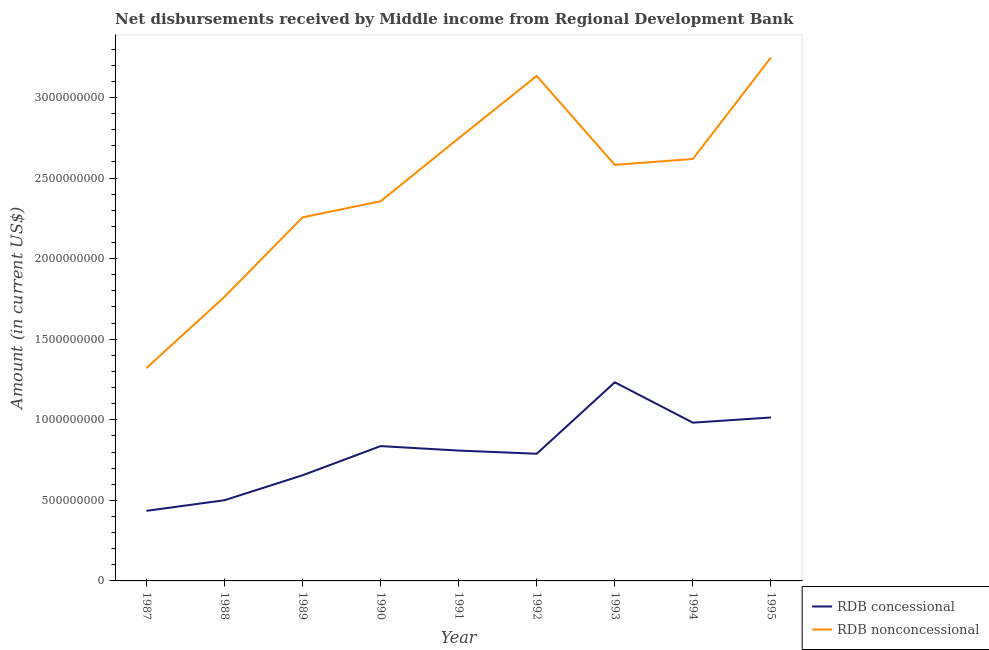Is the number of lines equal to the number of legend labels?
Your answer should be compact. Yes. What is the net non concessional disbursements from rdb in 1991?
Your response must be concise. 2.75e+09. Across all years, what is the maximum net non concessional disbursements from rdb?
Your answer should be compact. 3.25e+09. Across all years, what is the minimum net concessional disbursements from rdb?
Provide a short and direct response. 4.35e+08. In which year was the net concessional disbursements from rdb minimum?
Offer a very short reply. 1987. What is the total net non concessional disbursements from rdb in the graph?
Provide a short and direct response. 2.20e+1. What is the difference between the net concessional disbursements from rdb in 1992 and that in 1995?
Offer a terse response. -2.25e+08. What is the difference between the net concessional disbursements from rdb in 1991 and the net non concessional disbursements from rdb in 1987?
Provide a short and direct response. -5.12e+08. What is the average net concessional disbursements from rdb per year?
Ensure brevity in your answer.  8.06e+08. In the year 1993, what is the difference between the net non concessional disbursements from rdb and net concessional disbursements from rdb?
Offer a terse response. 1.35e+09. In how many years, is the net concessional disbursements from rdb greater than 1200000000 US$?
Your answer should be very brief. 1. What is the ratio of the net concessional disbursements from rdb in 1987 to that in 1990?
Offer a terse response. 0.52. Is the net concessional disbursements from rdb in 1991 less than that in 1994?
Keep it short and to the point. Yes. Is the difference between the net non concessional disbursements from rdb in 1989 and 1991 greater than the difference between the net concessional disbursements from rdb in 1989 and 1991?
Give a very brief answer. No. What is the difference between the highest and the second highest net concessional disbursements from rdb?
Offer a terse response. 2.18e+08. What is the difference between the highest and the lowest net concessional disbursements from rdb?
Provide a succinct answer. 7.98e+08. Is the sum of the net non concessional disbursements from rdb in 1987 and 1991 greater than the maximum net concessional disbursements from rdb across all years?
Make the answer very short. Yes. Is the net concessional disbursements from rdb strictly greater than the net non concessional disbursements from rdb over the years?
Keep it short and to the point. No. How many lines are there?
Provide a short and direct response. 2. What is the difference between two consecutive major ticks on the Y-axis?
Offer a terse response. 5.00e+08. Are the values on the major ticks of Y-axis written in scientific E-notation?
Make the answer very short. No. Does the graph contain any zero values?
Keep it short and to the point. No. Does the graph contain grids?
Offer a terse response. No. Where does the legend appear in the graph?
Your answer should be compact. Bottom right. What is the title of the graph?
Your answer should be compact. Net disbursements received by Middle income from Regional Development Bank. What is the label or title of the Y-axis?
Your answer should be very brief. Amount (in current US$). What is the Amount (in current US$) of RDB concessional in 1987?
Provide a succinct answer. 4.35e+08. What is the Amount (in current US$) of RDB nonconcessional in 1987?
Keep it short and to the point. 1.32e+09. What is the Amount (in current US$) in RDB concessional in 1988?
Your answer should be very brief. 5.01e+08. What is the Amount (in current US$) in RDB nonconcessional in 1988?
Provide a short and direct response. 1.76e+09. What is the Amount (in current US$) of RDB concessional in 1989?
Your answer should be very brief. 6.56e+08. What is the Amount (in current US$) in RDB nonconcessional in 1989?
Keep it short and to the point. 2.26e+09. What is the Amount (in current US$) in RDB concessional in 1990?
Provide a succinct answer. 8.37e+08. What is the Amount (in current US$) of RDB nonconcessional in 1990?
Provide a succinct answer. 2.36e+09. What is the Amount (in current US$) of RDB concessional in 1991?
Provide a short and direct response. 8.09e+08. What is the Amount (in current US$) of RDB nonconcessional in 1991?
Give a very brief answer. 2.75e+09. What is the Amount (in current US$) in RDB concessional in 1992?
Your answer should be very brief. 7.89e+08. What is the Amount (in current US$) of RDB nonconcessional in 1992?
Give a very brief answer. 3.13e+09. What is the Amount (in current US$) in RDB concessional in 1993?
Provide a short and direct response. 1.23e+09. What is the Amount (in current US$) in RDB nonconcessional in 1993?
Make the answer very short. 2.58e+09. What is the Amount (in current US$) of RDB concessional in 1994?
Provide a short and direct response. 9.82e+08. What is the Amount (in current US$) of RDB nonconcessional in 1994?
Your answer should be very brief. 2.62e+09. What is the Amount (in current US$) in RDB concessional in 1995?
Make the answer very short. 1.01e+09. What is the Amount (in current US$) in RDB nonconcessional in 1995?
Your answer should be compact. 3.25e+09. Across all years, what is the maximum Amount (in current US$) in RDB concessional?
Provide a succinct answer. 1.23e+09. Across all years, what is the maximum Amount (in current US$) of RDB nonconcessional?
Ensure brevity in your answer.  3.25e+09. Across all years, what is the minimum Amount (in current US$) in RDB concessional?
Keep it short and to the point. 4.35e+08. Across all years, what is the minimum Amount (in current US$) of RDB nonconcessional?
Ensure brevity in your answer.  1.32e+09. What is the total Amount (in current US$) in RDB concessional in the graph?
Offer a very short reply. 7.25e+09. What is the total Amount (in current US$) of RDB nonconcessional in the graph?
Provide a succinct answer. 2.20e+1. What is the difference between the Amount (in current US$) in RDB concessional in 1987 and that in 1988?
Your answer should be very brief. -6.59e+07. What is the difference between the Amount (in current US$) in RDB nonconcessional in 1987 and that in 1988?
Your response must be concise. -4.42e+08. What is the difference between the Amount (in current US$) of RDB concessional in 1987 and that in 1989?
Offer a terse response. -2.21e+08. What is the difference between the Amount (in current US$) in RDB nonconcessional in 1987 and that in 1989?
Offer a terse response. -9.35e+08. What is the difference between the Amount (in current US$) in RDB concessional in 1987 and that in 1990?
Provide a short and direct response. -4.02e+08. What is the difference between the Amount (in current US$) of RDB nonconcessional in 1987 and that in 1990?
Ensure brevity in your answer.  -1.04e+09. What is the difference between the Amount (in current US$) of RDB concessional in 1987 and that in 1991?
Provide a succinct answer. -3.74e+08. What is the difference between the Amount (in current US$) in RDB nonconcessional in 1987 and that in 1991?
Your answer should be very brief. -1.43e+09. What is the difference between the Amount (in current US$) in RDB concessional in 1987 and that in 1992?
Give a very brief answer. -3.54e+08. What is the difference between the Amount (in current US$) in RDB nonconcessional in 1987 and that in 1992?
Your answer should be very brief. -1.81e+09. What is the difference between the Amount (in current US$) of RDB concessional in 1987 and that in 1993?
Provide a short and direct response. -7.98e+08. What is the difference between the Amount (in current US$) in RDB nonconcessional in 1987 and that in 1993?
Your answer should be compact. -1.26e+09. What is the difference between the Amount (in current US$) in RDB concessional in 1987 and that in 1994?
Keep it short and to the point. -5.47e+08. What is the difference between the Amount (in current US$) of RDB nonconcessional in 1987 and that in 1994?
Your answer should be very brief. -1.30e+09. What is the difference between the Amount (in current US$) in RDB concessional in 1987 and that in 1995?
Your response must be concise. -5.79e+08. What is the difference between the Amount (in current US$) of RDB nonconcessional in 1987 and that in 1995?
Your answer should be very brief. -1.93e+09. What is the difference between the Amount (in current US$) in RDB concessional in 1988 and that in 1989?
Keep it short and to the point. -1.55e+08. What is the difference between the Amount (in current US$) of RDB nonconcessional in 1988 and that in 1989?
Your response must be concise. -4.93e+08. What is the difference between the Amount (in current US$) in RDB concessional in 1988 and that in 1990?
Offer a terse response. -3.36e+08. What is the difference between the Amount (in current US$) in RDB nonconcessional in 1988 and that in 1990?
Provide a succinct answer. -5.93e+08. What is the difference between the Amount (in current US$) of RDB concessional in 1988 and that in 1991?
Offer a very short reply. -3.08e+08. What is the difference between the Amount (in current US$) of RDB nonconcessional in 1988 and that in 1991?
Make the answer very short. -9.84e+08. What is the difference between the Amount (in current US$) of RDB concessional in 1988 and that in 1992?
Give a very brief answer. -2.88e+08. What is the difference between the Amount (in current US$) in RDB nonconcessional in 1988 and that in 1992?
Give a very brief answer. -1.37e+09. What is the difference between the Amount (in current US$) of RDB concessional in 1988 and that in 1993?
Provide a short and direct response. -7.32e+08. What is the difference between the Amount (in current US$) in RDB nonconcessional in 1988 and that in 1993?
Make the answer very short. -8.19e+08. What is the difference between the Amount (in current US$) of RDB concessional in 1988 and that in 1994?
Make the answer very short. -4.81e+08. What is the difference between the Amount (in current US$) in RDB nonconcessional in 1988 and that in 1994?
Offer a very short reply. -8.56e+08. What is the difference between the Amount (in current US$) of RDB concessional in 1988 and that in 1995?
Keep it short and to the point. -5.14e+08. What is the difference between the Amount (in current US$) of RDB nonconcessional in 1988 and that in 1995?
Your answer should be very brief. -1.49e+09. What is the difference between the Amount (in current US$) of RDB concessional in 1989 and that in 1990?
Provide a short and direct response. -1.81e+08. What is the difference between the Amount (in current US$) in RDB nonconcessional in 1989 and that in 1990?
Offer a very short reply. -1.00e+08. What is the difference between the Amount (in current US$) in RDB concessional in 1989 and that in 1991?
Your answer should be very brief. -1.53e+08. What is the difference between the Amount (in current US$) in RDB nonconcessional in 1989 and that in 1991?
Give a very brief answer. -4.91e+08. What is the difference between the Amount (in current US$) in RDB concessional in 1989 and that in 1992?
Make the answer very short. -1.34e+08. What is the difference between the Amount (in current US$) of RDB nonconcessional in 1989 and that in 1992?
Your answer should be very brief. -8.78e+08. What is the difference between the Amount (in current US$) in RDB concessional in 1989 and that in 1993?
Make the answer very short. -5.77e+08. What is the difference between the Amount (in current US$) in RDB nonconcessional in 1989 and that in 1993?
Give a very brief answer. -3.26e+08. What is the difference between the Amount (in current US$) of RDB concessional in 1989 and that in 1994?
Ensure brevity in your answer.  -3.26e+08. What is the difference between the Amount (in current US$) in RDB nonconcessional in 1989 and that in 1994?
Offer a very short reply. -3.62e+08. What is the difference between the Amount (in current US$) in RDB concessional in 1989 and that in 1995?
Keep it short and to the point. -3.59e+08. What is the difference between the Amount (in current US$) in RDB nonconcessional in 1989 and that in 1995?
Keep it short and to the point. -9.92e+08. What is the difference between the Amount (in current US$) in RDB concessional in 1990 and that in 1991?
Offer a very short reply. 2.78e+07. What is the difference between the Amount (in current US$) of RDB nonconcessional in 1990 and that in 1991?
Offer a very short reply. -3.90e+08. What is the difference between the Amount (in current US$) in RDB concessional in 1990 and that in 1992?
Your response must be concise. 4.75e+07. What is the difference between the Amount (in current US$) of RDB nonconcessional in 1990 and that in 1992?
Provide a short and direct response. -7.78e+08. What is the difference between the Amount (in current US$) in RDB concessional in 1990 and that in 1993?
Make the answer very short. -3.96e+08. What is the difference between the Amount (in current US$) in RDB nonconcessional in 1990 and that in 1993?
Offer a terse response. -2.26e+08. What is the difference between the Amount (in current US$) in RDB concessional in 1990 and that in 1994?
Give a very brief answer. -1.45e+08. What is the difference between the Amount (in current US$) of RDB nonconcessional in 1990 and that in 1994?
Offer a terse response. -2.62e+08. What is the difference between the Amount (in current US$) of RDB concessional in 1990 and that in 1995?
Provide a short and direct response. -1.78e+08. What is the difference between the Amount (in current US$) in RDB nonconcessional in 1990 and that in 1995?
Ensure brevity in your answer.  -8.92e+08. What is the difference between the Amount (in current US$) of RDB concessional in 1991 and that in 1992?
Keep it short and to the point. 1.97e+07. What is the difference between the Amount (in current US$) in RDB nonconcessional in 1991 and that in 1992?
Keep it short and to the point. -3.87e+08. What is the difference between the Amount (in current US$) of RDB concessional in 1991 and that in 1993?
Offer a terse response. -4.24e+08. What is the difference between the Amount (in current US$) in RDB nonconcessional in 1991 and that in 1993?
Give a very brief answer. 1.65e+08. What is the difference between the Amount (in current US$) of RDB concessional in 1991 and that in 1994?
Offer a terse response. -1.73e+08. What is the difference between the Amount (in current US$) in RDB nonconcessional in 1991 and that in 1994?
Make the answer very short. 1.28e+08. What is the difference between the Amount (in current US$) in RDB concessional in 1991 and that in 1995?
Offer a terse response. -2.05e+08. What is the difference between the Amount (in current US$) of RDB nonconcessional in 1991 and that in 1995?
Offer a terse response. -5.01e+08. What is the difference between the Amount (in current US$) of RDB concessional in 1992 and that in 1993?
Your response must be concise. -4.43e+08. What is the difference between the Amount (in current US$) of RDB nonconcessional in 1992 and that in 1993?
Offer a terse response. 5.52e+08. What is the difference between the Amount (in current US$) in RDB concessional in 1992 and that in 1994?
Your response must be concise. -1.93e+08. What is the difference between the Amount (in current US$) of RDB nonconcessional in 1992 and that in 1994?
Provide a succinct answer. 5.15e+08. What is the difference between the Amount (in current US$) of RDB concessional in 1992 and that in 1995?
Offer a very short reply. -2.25e+08. What is the difference between the Amount (in current US$) in RDB nonconcessional in 1992 and that in 1995?
Provide a short and direct response. -1.14e+08. What is the difference between the Amount (in current US$) in RDB concessional in 1993 and that in 1994?
Make the answer very short. 2.51e+08. What is the difference between the Amount (in current US$) in RDB nonconcessional in 1993 and that in 1994?
Provide a short and direct response. -3.67e+07. What is the difference between the Amount (in current US$) of RDB concessional in 1993 and that in 1995?
Your answer should be compact. 2.18e+08. What is the difference between the Amount (in current US$) in RDB nonconcessional in 1993 and that in 1995?
Provide a short and direct response. -6.66e+08. What is the difference between the Amount (in current US$) of RDB concessional in 1994 and that in 1995?
Your answer should be compact. -3.22e+07. What is the difference between the Amount (in current US$) in RDB nonconcessional in 1994 and that in 1995?
Keep it short and to the point. -6.29e+08. What is the difference between the Amount (in current US$) of RDB concessional in 1987 and the Amount (in current US$) of RDB nonconcessional in 1988?
Make the answer very short. -1.33e+09. What is the difference between the Amount (in current US$) of RDB concessional in 1987 and the Amount (in current US$) of RDB nonconcessional in 1989?
Keep it short and to the point. -1.82e+09. What is the difference between the Amount (in current US$) of RDB concessional in 1987 and the Amount (in current US$) of RDB nonconcessional in 1990?
Your response must be concise. -1.92e+09. What is the difference between the Amount (in current US$) in RDB concessional in 1987 and the Amount (in current US$) in RDB nonconcessional in 1991?
Provide a succinct answer. -2.31e+09. What is the difference between the Amount (in current US$) in RDB concessional in 1987 and the Amount (in current US$) in RDB nonconcessional in 1992?
Offer a very short reply. -2.70e+09. What is the difference between the Amount (in current US$) of RDB concessional in 1987 and the Amount (in current US$) of RDB nonconcessional in 1993?
Give a very brief answer. -2.15e+09. What is the difference between the Amount (in current US$) in RDB concessional in 1987 and the Amount (in current US$) in RDB nonconcessional in 1994?
Offer a terse response. -2.18e+09. What is the difference between the Amount (in current US$) in RDB concessional in 1987 and the Amount (in current US$) in RDB nonconcessional in 1995?
Provide a short and direct response. -2.81e+09. What is the difference between the Amount (in current US$) in RDB concessional in 1988 and the Amount (in current US$) in RDB nonconcessional in 1989?
Ensure brevity in your answer.  -1.76e+09. What is the difference between the Amount (in current US$) in RDB concessional in 1988 and the Amount (in current US$) in RDB nonconcessional in 1990?
Your answer should be compact. -1.86e+09. What is the difference between the Amount (in current US$) in RDB concessional in 1988 and the Amount (in current US$) in RDB nonconcessional in 1991?
Keep it short and to the point. -2.25e+09. What is the difference between the Amount (in current US$) in RDB concessional in 1988 and the Amount (in current US$) in RDB nonconcessional in 1992?
Provide a short and direct response. -2.63e+09. What is the difference between the Amount (in current US$) in RDB concessional in 1988 and the Amount (in current US$) in RDB nonconcessional in 1993?
Your answer should be compact. -2.08e+09. What is the difference between the Amount (in current US$) in RDB concessional in 1988 and the Amount (in current US$) in RDB nonconcessional in 1994?
Your answer should be very brief. -2.12e+09. What is the difference between the Amount (in current US$) of RDB concessional in 1988 and the Amount (in current US$) of RDB nonconcessional in 1995?
Your response must be concise. -2.75e+09. What is the difference between the Amount (in current US$) in RDB concessional in 1989 and the Amount (in current US$) in RDB nonconcessional in 1990?
Offer a very short reply. -1.70e+09. What is the difference between the Amount (in current US$) in RDB concessional in 1989 and the Amount (in current US$) in RDB nonconcessional in 1991?
Provide a succinct answer. -2.09e+09. What is the difference between the Amount (in current US$) of RDB concessional in 1989 and the Amount (in current US$) of RDB nonconcessional in 1992?
Make the answer very short. -2.48e+09. What is the difference between the Amount (in current US$) of RDB concessional in 1989 and the Amount (in current US$) of RDB nonconcessional in 1993?
Provide a short and direct response. -1.93e+09. What is the difference between the Amount (in current US$) of RDB concessional in 1989 and the Amount (in current US$) of RDB nonconcessional in 1994?
Offer a very short reply. -1.96e+09. What is the difference between the Amount (in current US$) of RDB concessional in 1989 and the Amount (in current US$) of RDB nonconcessional in 1995?
Offer a very short reply. -2.59e+09. What is the difference between the Amount (in current US$) of RDB concessional in 1990 and the Amount (in current US$) of RDB nonconcessional in 1991?
Your answer should be compact. -1.91e+09. What is the difference between the Amount (in current US$) in RDB concessional in 1990 and the Amount (in current US$) in RDB nonconcessional in 1992?
Offer a terse response. -2.30e+09. What is the difference between the Amount (in current US$) of RDB concessional in 1990 and the Amount (in current US$) of RDB nonconcessional in 1993?
Ensure brevity in your answer.  -1.75e+09. What is the difference between the Amount (in current US$) of RDB concessional in 1990 and the Amount (in current US$) of RDB nonconcessional in 1994?
Your response must be concise. -1.78e+09. What is the difference between the Amount (in current US$) in RDB concessional in 1990 and the Amount (in current US$) in RDB nonconcessional in 1995?
Ensure brevity in your answer.  -2.41e+09. What is the difference between the Amount (in current US$) of RDB concessional in 1991 and the Amount (in current US$) of RDB nonconcessional in 1992?
Give a very brief answer. -2.32e+09. What is the difference between the Amount (in current US$) in RDB concessional in 1991 and the Amount (in current US$) in RDB nonconcessional in 1993?
Make the answer very short. -1.77e+09. What is the difference between the Amount (in current US$) in RDB concessional in 1991 and the Amount (in current US$) in RDB nonconcessional in 1994?
Your answer should be compact. -1.81e+09. What is the difference between the Amount (in current US$) in RDB concessional in 1991 and the Amount (in current US$) in RDB nonconcessional in 1995?
Your response must be concise. -2.44e+09. What is the difference between the Amount (in current US$) of RDB concessional in 1992 and the Amount (in current US$) of RDB nonconcessional in 1993?
Offer a very short reply. -1.79e+09. What is the difference between the Amount (in current US$) in RDB concessional in 1992 and the Amount (in current US$) in RDB nonconcessional in 1994?
Make the answer very short. -1.83e+09. What is the difference between the Amount (in current US$) in RDB concessional in 1992 and the Amount (in current US$) in RDB nonconcessional in 1995?
Give a very brief answer. -2.46e+09. What is the difference between the Amount (in current US$) of RDB concessional in 1993 and the Amount (in current US$) of RDB nonconcessional in 1994?
Give a very brief answer. -1.39e+09. What is the difference between the Amount (in current US$) of RDB concessional in 1993 and the Amount (in current US$) of RDB nonconcessional in 1995?
Your answer should be compact. -2.02e+09. What is the difference between the Amount (in current US$) of RDB concessional in 1994 and the Amount (in current US$) of RDB nonconcessional in 1995?
Your answer should be very brief. -2.27e+09. What is the average Amount (in current US$) in RDB concessional per year?
Ensure brevity in your answer.  8.06e+08. What is the average Amount (in current US$) of RDB nonconcessional per year?
Your answer should be very brief. 2.45e+09. In the year 1987, what is the difference between the Amount (in current US$) in RDB concessional and Amount (in current US$) in RDB nonconcessional?
Provide a succinct answer. -8.86e+08. In the year 1988, what is the difference between the Amount (in current US$) of RDB concessional and Amount (in current US$) of RDB nonconcessional?
Your answer should be very brief. -1.26e+09. In the year 1989, what is the difference between the Amount (in current US$) in RDB concessional and Amount (in current US$) in RDB nonconcessional?
Offer a terse response. -1.60e+09. In the year 1990, what is the difference between the Amount (in current US$) in RDB concessional and Amount (in current US$) in RDB nonconcessional?
Keep it short and to the point. -1.52e+09. In the year 1991, what is the difference between the Amount (in current US$) in RDB concessional and Amount (in current US$) in RDB nonconcessional?
Your answer should be compact. -1.94e+09. In the year 1992, what is the difference between the Amount (in current US$) in RDB concessional and Amount (in current US$) in RDB nonconcessional?
Your answer should be compact. -2.34e+09. In the year 1993, what is the difference between the Amount (in current US$) in RDB concessional and Amount (in current US$) in RDB nonconcessional?
Your response must be concise. -1.35e+09. In the year 1994, what is the difference between the Amount (in current US$) in RDB concessional and Amount (in current US$) in RDB nonconcessional?
Your answer should be very brief. -1.64e+09. In the year 1995, what is the difference between the Amount (in current US$) in RDB concessional and Amount (in current US$) in RDB nonconcessional?
Your response must be concise. -2.23e+09. What is the ratio of the Amount (in current US$) of RDB concessional in 1987 to that in 1988?
Provide a short and direct response. 0.87. What is the ratio of the Amount (in current US$) in RDB nonconcessional in 1987 to that in 1988?
Ensure brevity in your answer.  0.75. What is the ratio of the Amount (in current US$) in RDB concessional in 1987 to that in 1989?
Your response must be concise. 0.66. What is the ratio of the Amount (in current US$) of RDB nonconcessional in 1987 to that in 1989?
Keep it short and to the point. 0.59. What is the ratio of the Amount (in current US$) in RDB concessional in 1987 to that in 1990?
Keep it short and to the point. 0.52. What is the ratio of the Amount (in current US$) in RDB nonconcessional in 1987 to that in 1990?
Keep it short and to the point. 0.56. What is the ratio of the Amount (in current US$) in RDB concessional in 1987 to that in 1991?
Provide a short and direct response. 0.54. What is the ratio of the Amount (in current US$) in RDB nonconcessional in 1987 to that in 1991?
Ensure brevity in your answer.  0.48. What is the ratio of the Amount (in current US$) in RDB concessional in 1987 to that in 1992?
Your response must be concise. 0.55. What is the ratio of the Amount (in current US$) of RDB nonconcessional in 1987 to that in 1992?
Offer a terse response. 0.42. What is the ratio of the Amount (in current US$) of RDB concessional in 1987 to that in 1993?
Your answer should be compact. 0.35. What is the ratio of the Amount (in current US$) of RDB nonconcessional in 1987 to that in 1993?
Make the answer very short. 0.51. What is the ratio of the Amount (in current US$) of RDB concessional in 1987 to that in 1994?
Keep it short and to the point. 0.44. What is the ratio of the Amount (in current US$) of RDB nonconcessional in 1987 to that in 1994?
Make the answer very short. 0.5. What is the ratio of the Amount (in current US$) in RDB concessional in 1987 to that in 1995?
Your answer should be compact. 0.43. What is the ratio of the Amount (in current US$) in RDB nonconcessional in 1987 to that in 1995?
Ensure brevity in your answer.  0.41. What is the ratio of the Amount (in current US$) in RDB concessional in 1988 to that in 1989?
Offer a very short reply. 0.76. What is the ratio of the Amount (in current US$) of RDB nonconcessional in 1988 to that in 1989?
Give a very brief answer. 0.78. What is the ratio of the Amount (in current US$) in RDB concessional in 1988 to that in 1990?
Give a very brief answer. 0.6. What is the ratio of the Amount (in current US$) in RDB nonconcessional in 1988 to that in 1990?
Your response must be concise. 0.75. What is the ratio of the Amount (in current US$) in RDB concessional in 1988 to that in 1991?
Make the answer very short. 0.62. What is the ratio of the Amount (in current US$) in RDB nonconcessional in 1988 to that in 1991?
Your response must be concise. 0.64. What is the ratio of the Amount (in current US$) of RDB concessional in 1988 to that in 1992?
Your answer should be very brief. 0.63. What is the ratio of the Amount (in current US$) in RDB nonconcessional in 1988 to that in 1992?
Your answer should be compact. 0.56. What is the ratio of the Amount (in current US$) in RDB concessional in 1988 to that in 1993?
Provide a succinct answer. 0.41. What is the ratio of the Amount (in current US$) in RDB nonconcessional in 1988 to that in 1993?
Provide a short and direct response. 0.68. What is the ratio of the Amount (in current US$) of RDB concessional in 1988 to that in 1994?
Your answer should be very brief. 0.51. What is the ratio of the Amount (in current US$) in RDB nonconcessional in 1988 to that in 1994?
Provide a short and direct response. 0.67. What is the ratio of the Amount (in current US$) of RDB concessional in 1988 to that in 1995?
Keep it short and to the point. 0.49. What is the ratio of the Amount (in current US$) of RDB nonconcessional in 1988 to that in 1995?
Your answer should be compact. 0.54. What is the ratio of the Amount (in current US$) in RDB concessional in 1989 to that in 1990?
Ensure brevity in your answer.  0.78. What is the ratio of the Amount (in current US$) in RDB nonconcessional in 1989 to that in 1990?
Offer a very short reply. 0.96. What is the ratio of the Amount (in current US$) in RDB concessional in 1989 to that in 1991?
Offer a very short reply. 0.81. What is the ratio of the Amount (in current US$) in RDB nonconcessional in 1989 to that in 1991?
Provide a succinct answer. 0.82. What is the ratio of the Amount (in current US$) in RDB concessional in 1989 to that in 1992?
Provide a short and direct response. 0.83. What is the ratio of the Amount (in current US$) in RDB nonconcessional in 1989 to that in 1992?
Your answer should be compact. 0.72. What is the ratio of the Amount (in current US$) of RDB concessional in 1989 to that in 1993?
Give a very brief answer. 0.53. What is the ratio of the Amount (in current US$) in RDB nonconcessional in 1989 to that in 1993?
Your answer should be compact. 0.87. What is the ratio of the Amount (in current US$) of RDB concessional in 1989 to that in 1994?
Provide a succinct answer. 0.67. What is the ratio of the Amount (in current US$) in RDB nonconcessional in 1989 to that in 1994?
Offer a very short reply. 0.86. What is the ratio of the Amount (in current US$) of RDB concessional in 1989 to that in 1995?
Keep it short and to the point. 0.65. What is the ratio of the Amount (in current US$) in RDB nonconcessional in 1989 to that in 1995?
Your answer should be compact. 0.69. What is the ratio of the Amount (in current US$) in RDB concessional in 1990 to that in 1991?
Your response must be concise. 1.03. What is the ratio of the Amount (in current US$) of RDB nonconcessional in 1990 to that in 1991?
Provide a succinct answer. 0.86. What is the ratio of the Amount (in current US$) of RDB concessional in 1990 to that in 1992?
Your answer should be compact. 1.06. What is the ratio of the Amount (in current US$) of RDB nonconcessional in 1990 to that in 1992?
Keep it short and to the point. 0.75. What is the ratio of the Amount (in current US$) in RDB concessional in 1990 to that in 1993?
Provide a succinct answer. 0.68. What is the ratio of the Amount (in current US$) of RDB nonconcessional in 1990 to that in 1993?
Your answer should be compact. 0.91. What is the ratio of the Amount (in current US$) of RDB concessional in 1990 to that in 1994?
Offer a very short reply. 0.85. What is the ratio of the Amount (in current US$) of RDB nonconcessional in 1990 to that in 1994?
Offer a very short reply. 0.9. What is the ratio of the Amount (in current US$) in RDB concessional in 1990 to that in 1995?
Make the answer very short. 0.82. What is the ratio of the Amount (in current US$) in RDB nonconcessional in 1990 to that in 1995?
Provide a short and direct response. 0.73. What is the ratio of the Amount (in current US$) in RDB concessional in 1991 to that in 1992?
Ensure brevity in your answer.  1.02. What is the ratio of the Amount (in current US$) of RDB nonconcessional in 1991 to that in 1992?
Provide a short and direct response. 0.88. What is the ratio of the Amount (in current US$) in RDB concessional in 1991 to that in 1993?
Keep it short and to the point. 0.66. What is the ratio of the Amount (in current US$) of RDB nonconcessional in 1991 to that in 1993?
Your response must be concise. 1.06. What is the ratio of the Amount (in current US$) of RDB concessional in 1991 to that in 1994?
Offer a terse response. 0.82. What is the ratio of the Amount (in current US$) in RDB nonconcessional in 1991 to that in 1994?
Keep it short and to the point. 1.05. What is the ratio of the Amount (in current US$) of RDB concessional in 1991 to that in 1995?
Your response must be concise. 0.8. What is the ratio of the Amount (in current US$) of RDB nonconcessional in 1991 to that in 1995?
Keep it short and to the point. 0.85. What is the ratio of the Amount (in current US$) of RDB concessional in 1992 to that in 1993?
Offer a very short reply. 0.64. What is the ratio of the Amount (in current US$) of RDB nonconcessional in 1992 to that in 1993?
Provide a short and direct response. 1.21. What is the ratio of the Amount (in current US$) of RDB concessional in 1992 to that in 1994?
Keep it short and to the point. 0.8. What is the ratio of the Amount (in current US$) of RDB nonconcessional in 1992 to that in 1994?
Provide a succinct answer. 1.2. What is the ratio of the Amount (in current US$) in RDB concessional in 1992 to that in 1995?
Keep it short and to the point. 0.78. What is the ratio of the Amount (in current US$) of RDB nonconcessional in 1992 to that in 1995?
Your answer should be compact. 0.96. What is the ratio of the Amount (in current US$) of RDB concessional in 1993 to that in 1994?
Ensure brevity in your answer.  1.26. What is the ratio of the Amount (in current US$) of RDB nonconcessional in 1993 to that in 1994?
Your answer should be very brief. 0.99. What is the ratio of the Amount (in current US$) in RDB concessional in 1993 to that in 1995?
Your answer should be compact. 1.22. What is the ratio of the Amount (in current US$) in RDB nonconcessional in 1993 to that in 1995?
Make the answer very short. 0.79. What is the ratio of the Amount (in current US$) of RDB concessional in 1994 to that in 1995?
Your response must be concise. 0.97. What is the ratio of the Amount (in current US$) in RDB nonconcessional in 1994 to that in 1995?
Give a very brief answer. 0.81. What is the difference between the highest and the second highest Amount (in current US$) in RDB concessional?
Give a very brief answer. 2.18e+08. What is the difference between the highest and the second highest Amount (in current US$) of RDB nonconcessional?
Keep it short and to the point. 1.14e+08. What is the difference between the highest and the lowest Amount (in current US$) in RDB concessional?
Make the answer very short. 7.98e+08. What is the difference between the highest and the lowest Amount (in current US$) in RDB nonconcessional?
Your response must be concise. 1.93e+09. 